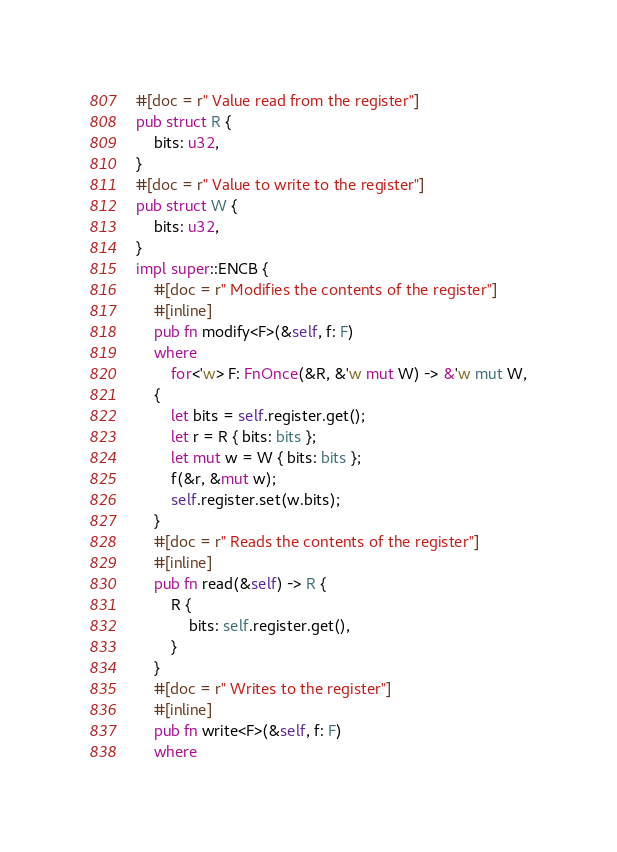<code> <loc_0><loc_0><loc_500><loc_500><_Rust_>#[doc = r" Value read from the register"]
pub struct R {
    bits: u32,
}
#[doc = r" Value to write to the register"]
pub struct W {
    bits: u32,
}
impl super::ENCB {
    #[doc = r" Modifies the contents of the register"]
    #[inline]
    pub fn modify<F>(&self, f: F)
    where
        for<'w> F: FnOnce(&R, &'w mut W) -> &'w mut W,
    {
        let bits = self.register.get();
        let r = R { bits: bits };
        let mut w = W { bits: bits };
        f(&r, &mut w);
        self.register.set(w.bits);
    }
    #[doc = r" Reads the contents of the register"]
    #[inline]
    pub fn read(&self) -> R {
        R {
            bits: self.register.get(),
        }
    }
    #[doc = r" Writes to the register"]
    #[inline]
    pub fn write<F>(&self, f: F)
    where</code> 